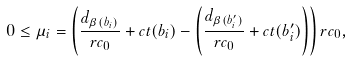Convert formula to latex. <formula><loc_0><loc_0><loc_500><loc_500>0 \leq \mu _ { i } = \left ( \frac { d _ { \beta ( b _ { i } ) } } { r c _ { 0 } } + c t ( b _ { i } ) - \left ( \frac { d _ { \beta ( b _ { i } ^ { \prime } ) } } { r c _ { 0 } } + c t ( b _ { i } ^ { \prime } ) \right ) \right ) r c _ { 0 } ,</formula> 